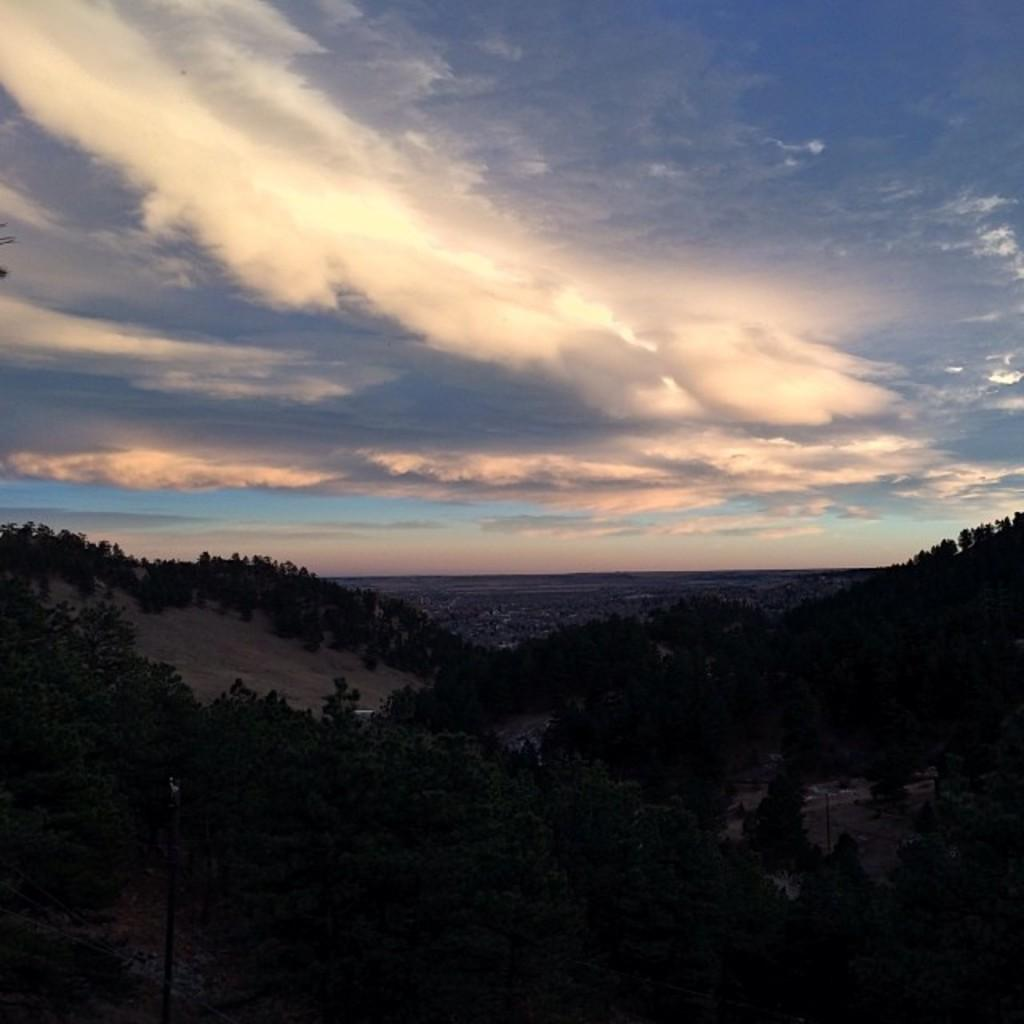What type of vegetation can be seen in the foreground of the image? There are trees in the foreground of the image. What type of urban environment is visible in the background of the image? There is a city visible in the background of the image. What part of the natural environment is visible in the background of the image? The sky is visible in the background of the image. What can be observed in the sky in the image? There is a cloud in the sky. What degree of difficulty is required to open the drawer in the image? There is no drawer present in the image, so the degree of difficulty cannot be determined. 